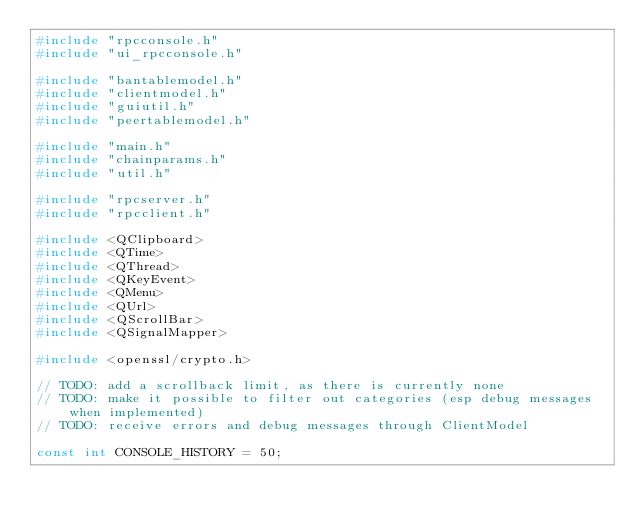<code> <loc_0><loc_0><loc_500><loc_500><_C++_>#include "rpcconsole.h"
#include "ui_rpcconsole.h"

#include "bantablemodel.h"
#include "clientmodel.h"
#include "guiutil.h"
#include "peertablemodel.h"

#include "main.h"
#include "chainparams.h"
#include "util.h"

#include "rpcserver.h"
#include "rpcclient.h"

#include <QClipboard>
#include <QTime>
#include <QThread>
#include <QKeyEvent>
#include <QMenu>
#include <QUrl>
#include <QScrollBar>
#include <QSignalMapper>

#include <openssl/crypto.h>

// TODO: add a scrollback limit, as there is currently none
// TODO: make it possible to filter out categories (esp debug messages when implemented)
// TODO: receive errors and debug messages through ClientModel

const int CONSOLE_HISTORY = 50;</code> 